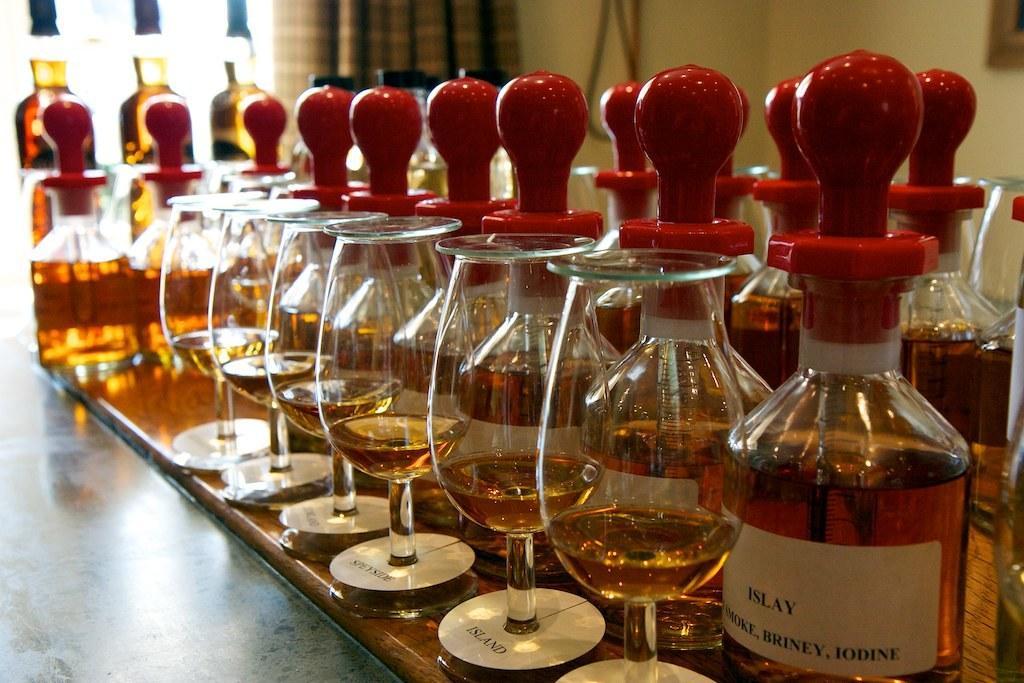Could you give a brief overview of what you see in this image? In this image I can see a couple of glass bottles and glasses on a table. 